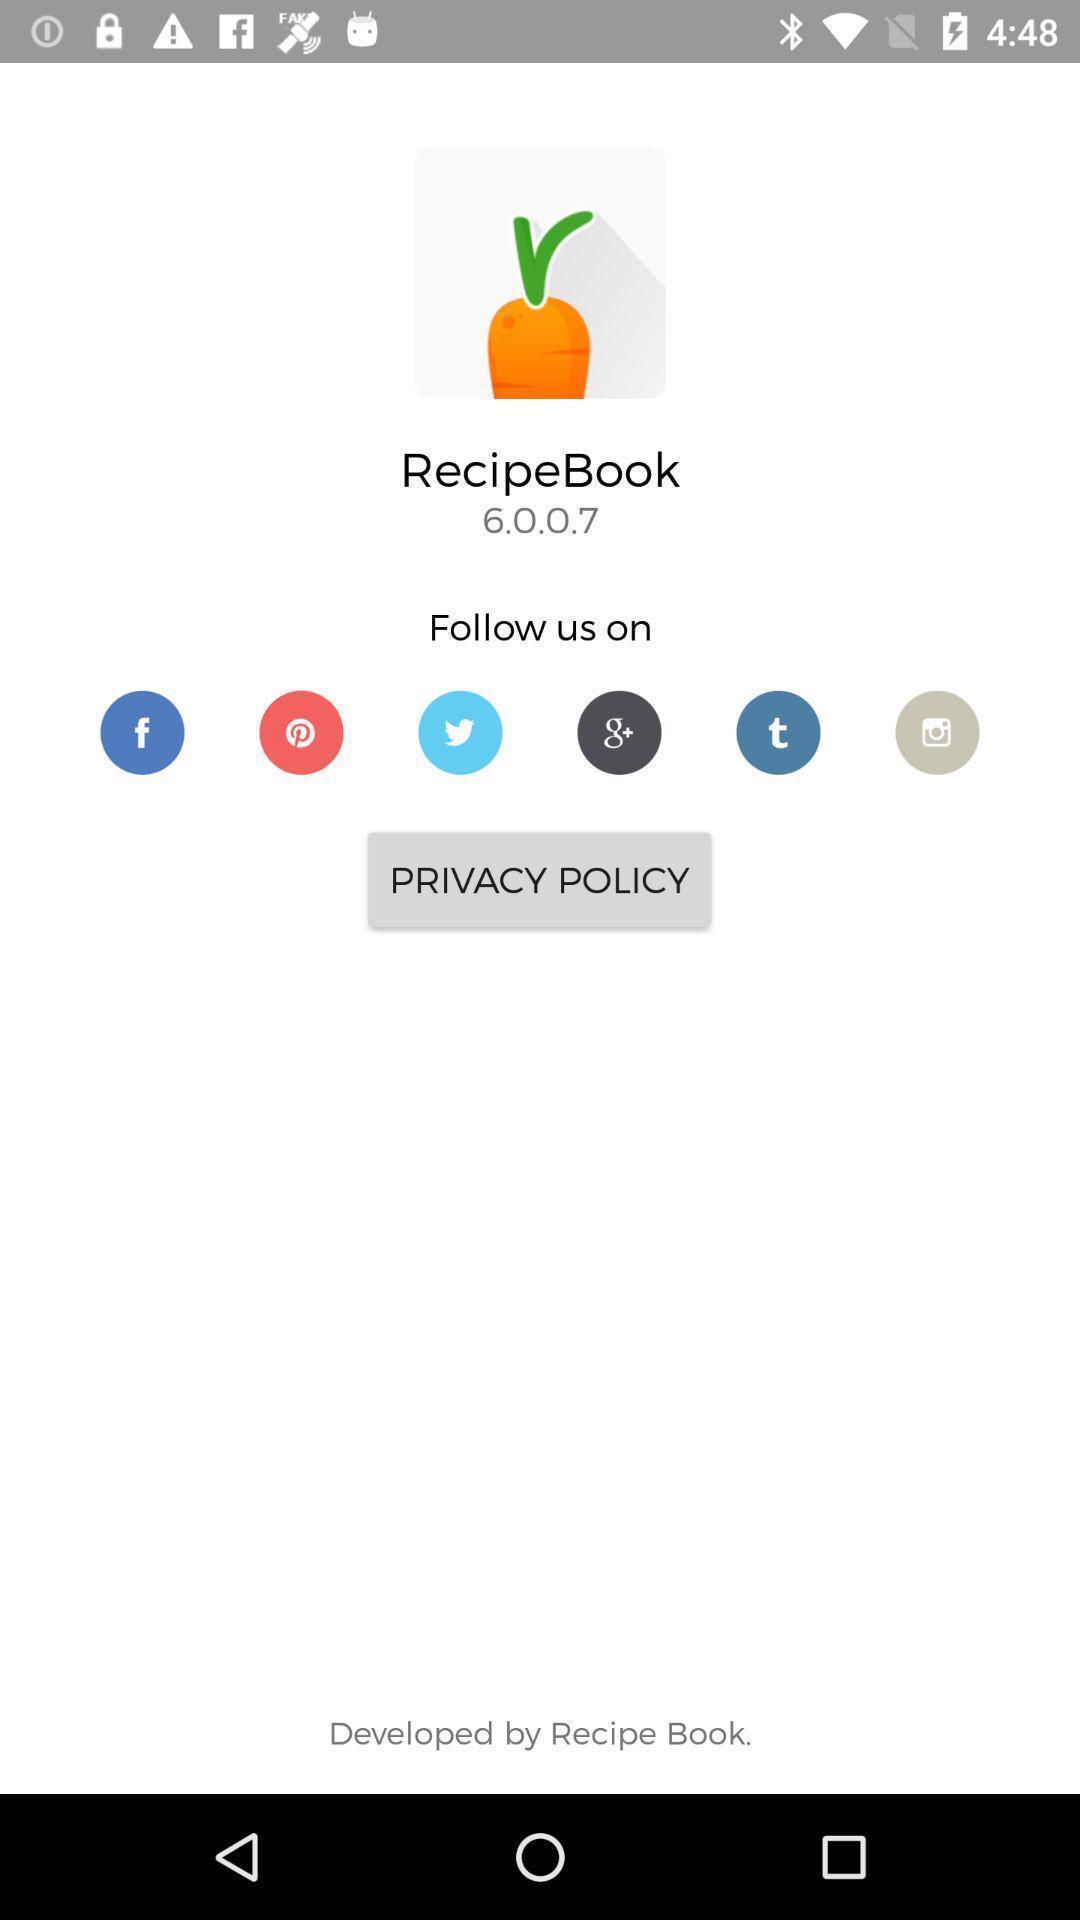Summarize the information in this screenshot. Welcome page of a cooking app. 